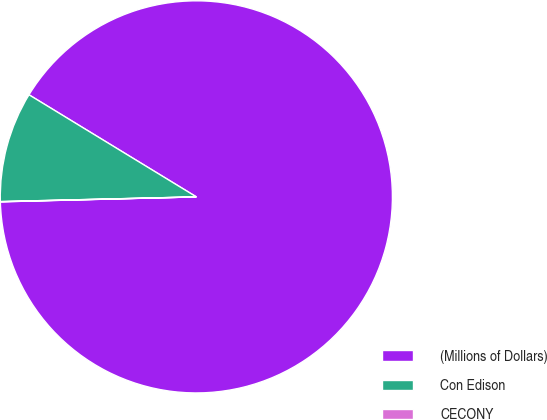Convert chart to OTSL. <chart><loc_0><loc_0><loc_500><loc_500><pie_chart><fcel>(Millions of Dollars)<fcel>Con Edison<fcel>CECONY<nl><fcel>90.88%<fcel>9.1%<fcel>0.02%<nl></chart> 